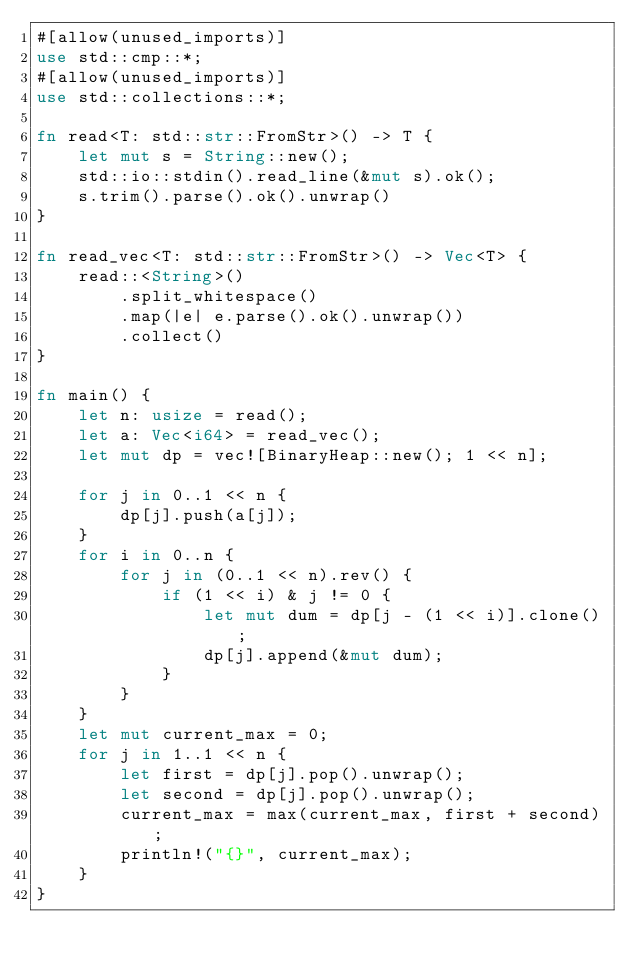<code> <loc_0><loc_0><loc_500><loc_500><_Rust_>#[allow(unused_imports)]
use std::cmp::*;
#[allow(unused_imports)]
use std::collections::*;

fn read<T: std::str::FromStr>() -> T {
    let mut s = String::new();
    std::io::stdin().read_line(&mut s).ok();
    s.trim().parse().ok().unwrap()
}

fn read_vec<T: std::str::FromStr>() -> Vec<T> {
    read::<String>()
        .split_whitespace()
        .map(|e| e.parse().ok().unwrap())
        .collect()
}

fn main() {
    let n: usize = read();
    let a: Vec<i64> = read_vec();
    let mut dp = vec![BinaryHeap::new(); 1 << n];

    for j in 0..1 << n {
        dp[j].push(a[j]);
    }
    for i in 0..n {
        for j in (0..1 << n).rev() {
            if (1 << i) & j != 0 {
                let mut dum = dp[j - (1 << i)].clone();
                dp[j].append(&mut dum);
            }
        }
    }
    let mut current_max = 0;
    for j in 1..1 << n {
        let first = dp[j].pop().unwrap();
        let second = dp[j].pop().unwrap();
        current_max = max(current_max, first + second);
        println!("{}", current_max);
    }
}
</code> 